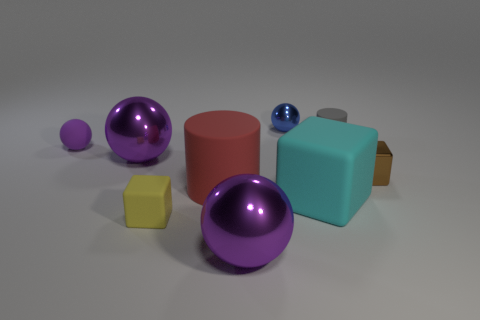Is the size of the cyan rubber cube the same as the blue thing?
Provide a short and direct response. No. Are there more tiny cubes that are right of the large cyan rubber cube than big red cylinders right of the red matte cylinder?
Ensure brevity in your answer.  Yes. How many other things are the same size as the brown metal cube?
Your answer should be very brief. 4. Does the metallic sphere that is to the left of the yellow rubber object have the same color as the rubber sphere?
Offer a terse response. Yes. Are there more tiny things in front of the blue metallic ball than tiny yellow objects?
Your answer should be compact. Yes. Is there any other thing that is the same color as the matte ball?
Keep it short and to the point. Yes. There is a matte object on the left side of the yellow object that is in front of the large cylinder; what is its shape?
Ensure brevity in your answer.  Sphere. Is the number of small brown objects greater than the number of spheres?
Offer a very short reply. No. How many small objects are both on the left side of the brown metallic block and behind the large red cylinder?
Provide a short and direct response. 3. What number of small metal blocks are to the left of the cylinder that is in front of the purple matte ball?
Keep it short and to the point. 0. 